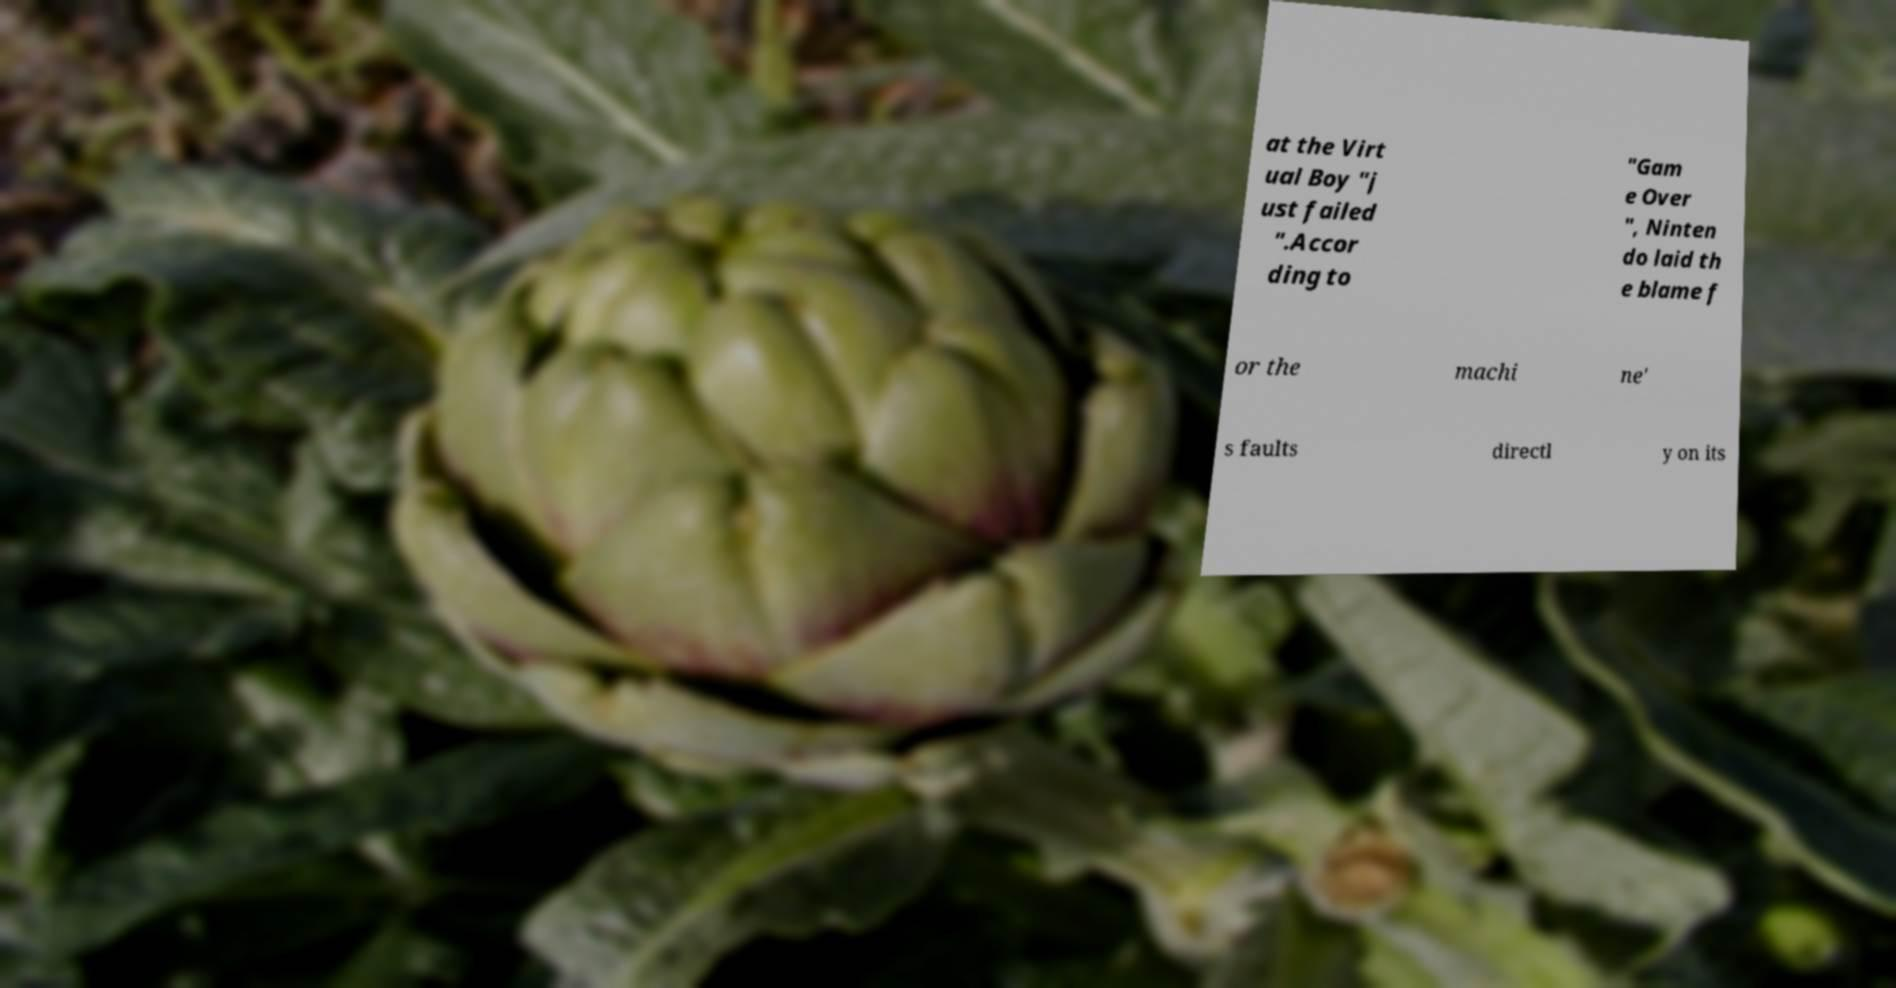Could you extract and type out the text from this image? at the Virt ual Boy "j ust failed ".Accor ding to "Gam e Over ", Ninten do laid th e blame f or the machi ne' s faults directl y on its 